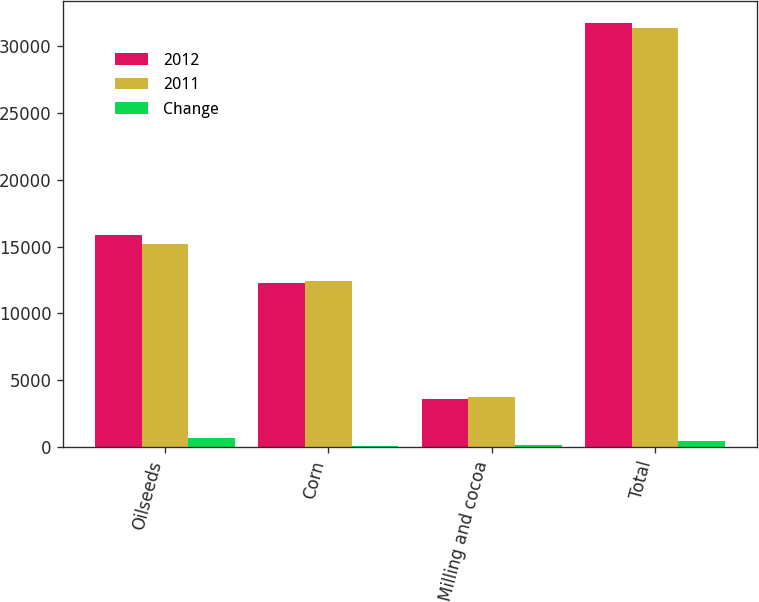<chart> <loc_0><loc_0><loc_500><loc_500><stacked_bar_chart><ecel><fcel>Oilseeds<fcel>Corn<fcel>Milling and cocoa<fcel>Total<nl><fcel>2012<fcel>15868<fcel>12307<fcel>3603<fcel>31778<nl><fcel>2011<fcel>15209<fcel>12408<fcel>3736<fcel>31353<nl><fcel>Change<fcel>659<fcel>101<fcel>133<fcel>425<nl></chart> 